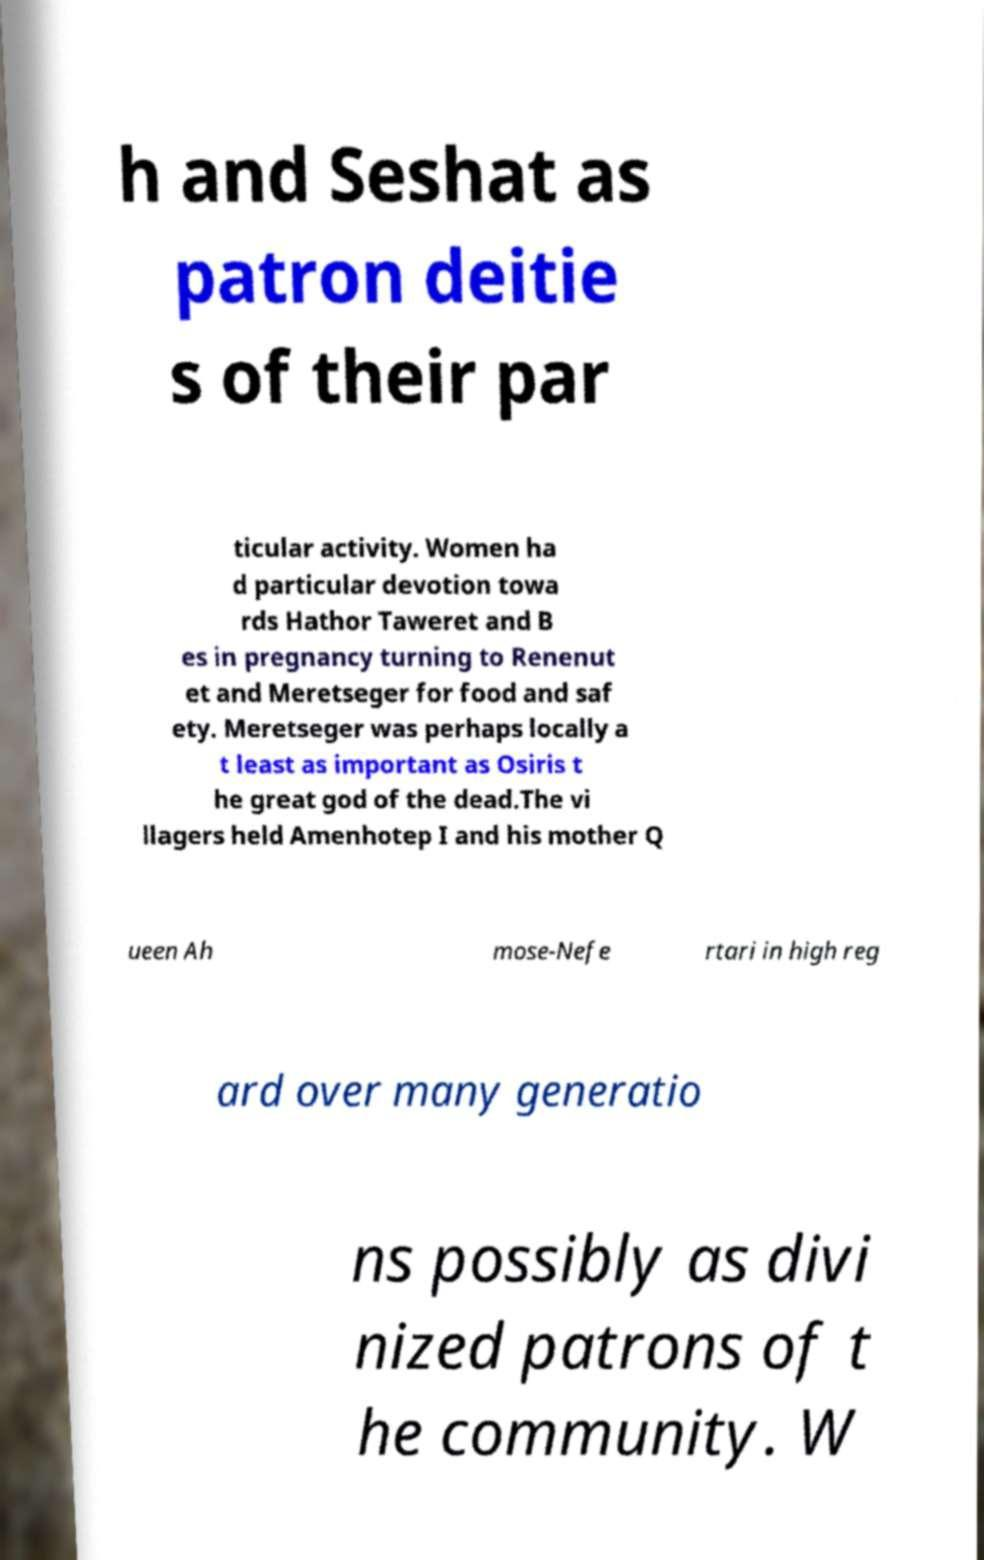What messages or text are displayed in this image? I need them in a readable, typed format. h and Seshat as patron deitie s of their par ticular activity. Women ha d particular devotion towa rds Hathor Taweret and B es in pregnancy turning to Renenut et and Meretseger for food and saf ety. Meretseger was perhaps locally a t least as important as Osiris t he great god of the dead.The vi llagers held Amenhotep I and his mother Q ueen Ah mose-Nefe rtari in high reg ard over many generatio ns possibly as divi nized patrons of t he community. W 